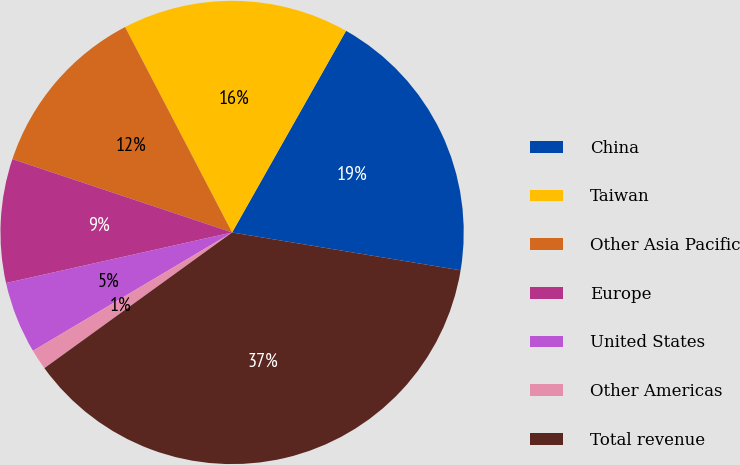Convert chart. <chart><loc_0><loc_0><loc_500><loc_500><pie_chart><fcel>China<fcel>Taiwan<fcel>Other Asia Pacific<fcel>Europe<fcel>United States<fcel>Other Americas<fcel>Total revenue<nl><fcel>19.43%<fcel>15.83%<fcel>12.23%<fcel>8.63%<fcel>5.03%<fcel>1.43%<fcel>37.43%<nl></chart> 